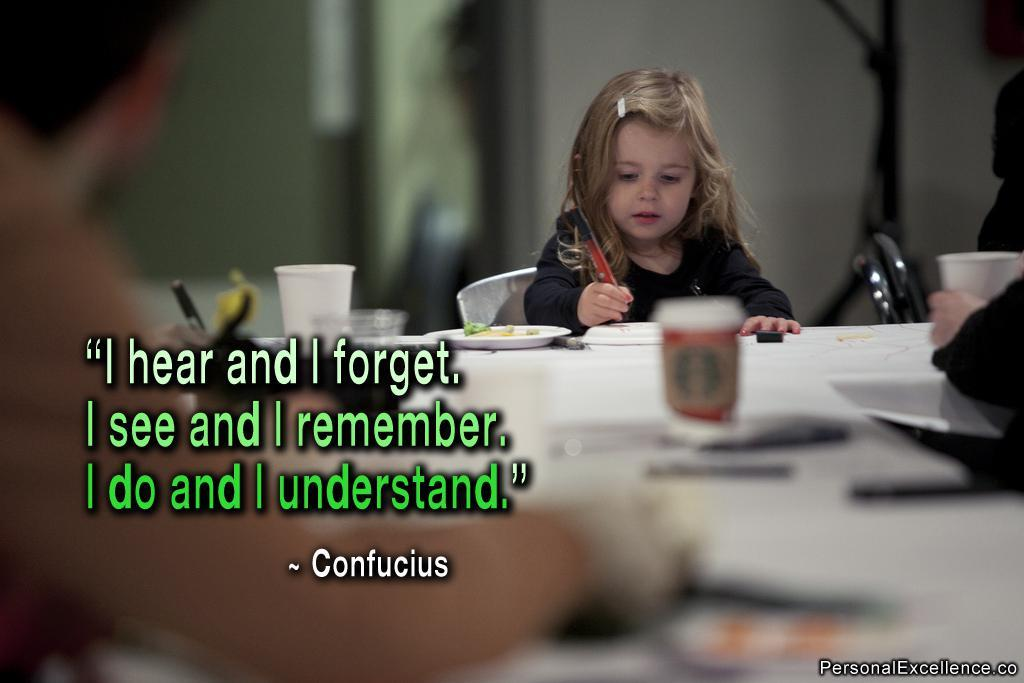What is the main subject of the image? There is a child in the image. What is the child doing in the image? The child is sitting on a chair. What is in front of the child? There is a table in front of the child. What can be seen on the table? There are multiple objects on the table. What type of tank can be seen in the garden behind the child? There is no tank or garden present in the image; it only features a child sitting on a chair with a table in front of them. 